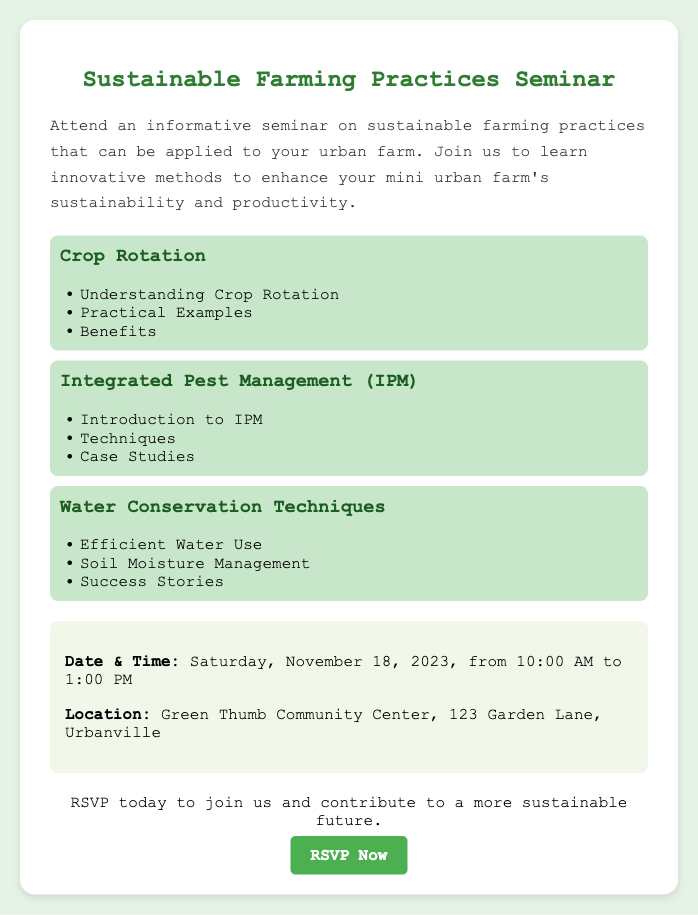What is the title of the seminar? The title of the seminar is explicitly mentioned in the document.
Answer: Sustainable Farming Practices Seminar When is the seminar scheduled? The document provides the specific date and time of the event.
Answer: Saturday, November 18, 2023, from 10:00 AM to 1:00 PM Where will the seminar take place? The location of the seminar is stated in the document under the information section.
Answer: Green Thumb Community Center, 123 Garden Lane, Urbanville What is one topic covered in the seminar? The document lists several topics that will be discussed during the seminar.
Answer: Crop Rotation How does the seminar contribute to sustainability? The document mentions that the seminar aims to enhance sustainability and productivity in urban farms.
Answer: Contributes to a more sustainable future What should attendees do to participate in the seminar? The document includes a call to action encouraging attendees to take a specific step to join.
Answer: RSVP Which pest management approach is included in the topics? The seminar covers various topics including pest management methodologies.
Answer: Integrated Pest Management What type of techniques will be discussed regarding water? The document specifies the focus on techniques related to water conservation methods.
Answer: Water Conservation Techniques 